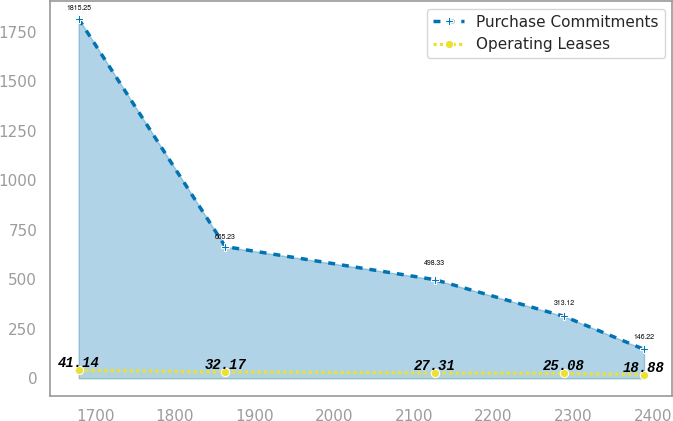Convert chart. <chart><loc_0><loc_0><loc_500><loc_500><line_chart><ecel><fcel>Purchase Commitments<fcel>Operating Leases<nl><fcel>1679.23<fcel>1815.25<fcel>41.14<nl><fcel>1863.34<fcel>665.23<fcel>32.17<nl><fcel>2126.46<fcel>498.33<fcel>27.31<nl><fcel>2288.68<fcel>313.12<fcel>25.08<nl><fcel>2389.21<fcel>146.22<fcel>18.88<nl></chart> 